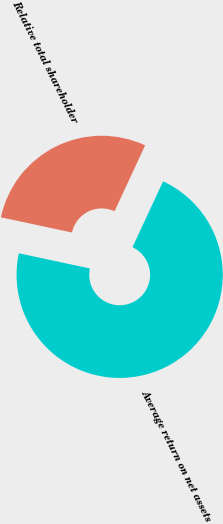Convert chart to OTSL. <chart><loc_0><loc_0><loc_500><loc_500><pie_chart><fcel>Average return on net assets<fcel>Relative total shareholder<nl><fcel>71.43%<fcel>28.57%<nl></chart> 